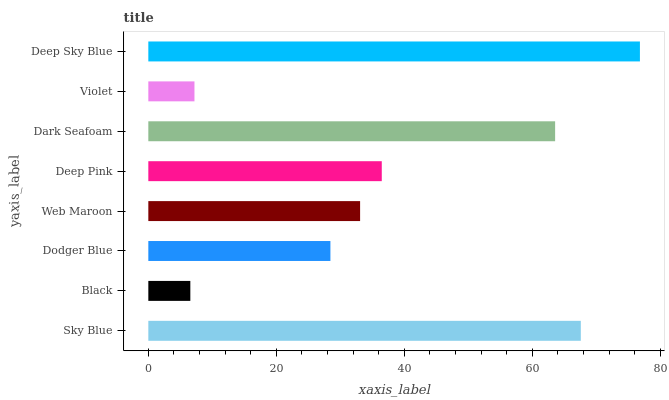Is Black the minimum?
Answer yes or no. Yes. Is Deep Sky Blue the maximum?
Answer yes or no. Yes. Is Dodger Blue the minimum?
Answer yes or no. No. Is Dodger Blue the maximum?
Answer yes or no. No. Is Dodger Blue greater than Black?
Answer yes or no. Yes. Is Black less than Dodger Blue?
Answer yes or no. Yes. Is Black greater than Dodger Blue?
Answer yes or no. No. Is Dodger Blue less than Black?
Answer yes or no. No. Is Deep Pink the high median?
Answer yes or no. Yes. Is Web Maroon the low median?
Answer yes or no. Yes. Is Web Maroon the high median?
Answer yes or no. No. Is Black the low median?
Answer yes or no. No. 